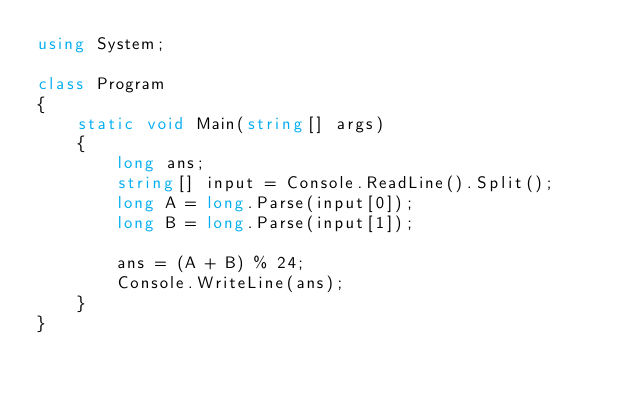<code> <loc_0><loc_0><loc_500><loc_500><_C#_>using System;

class Program
{
    static void Main(string[] args)
    {
        long ans;
        string[] input = Console.ReadLine().Split();
        long A = long.Parse(input[0]);
        long B = long.Parse(input[1]);

        ans = (A + B) % 24;
        Console.WriteLine(ans);
    }
}</code> 